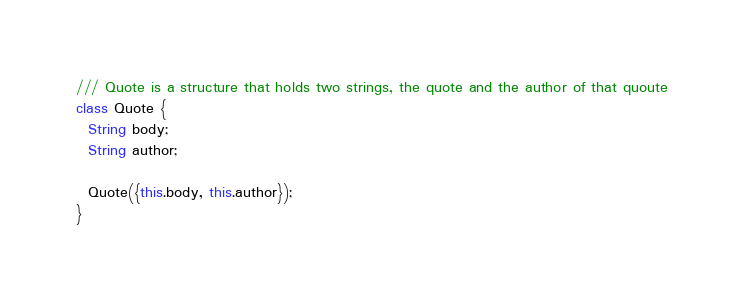<code> <loc_0><loc_0><loc_500><loc_500><_Dart_>/// Quote is a structure that holds two strings, the quote and the author of that quoute
class Quote {
  String body;
  String author;

  Quote({this.body, this.author});
}
</code> 